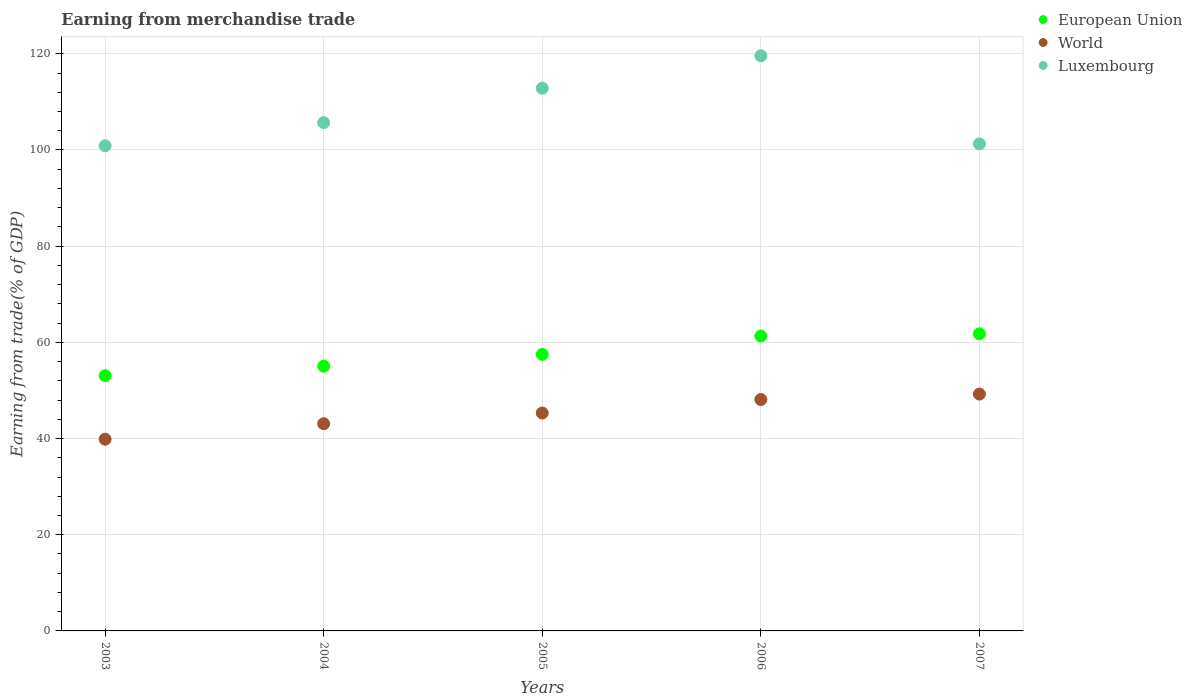How many different coloured dotlines are there?
Offer a terse response. 3. What is the earnings from trade in World in 2003?
Your answer should be compact. 39.86. Across all years, what is the maximum earnings from trade in World?
Your answer should be very brief. 49.24. Across all years, what is the minimum earnings from trade in European Union?
Offer a terse response. 53.07. In which year was the earnings from trade in Luxembourg maximum?
Your answer should be compact. 2006. What is the total earnings from trade in World in the graph?
Your response must be concise. 225.61. What is the difference between the earnings from trade in World in 2004 and that in 2005?
Your answer should be very brief. -2.23. What is the difference between the earnings from trade in European Union in 2004 and the earnings from trade in Luxembourg in 2003?
Offer a terse response. -45.81. What is the average earnings from trade in European Union per year?
Provide a succinct answer. 57.75. In the year 2006, what is the difference between the earnings from trade in Luxembourg and earnings from trade in European Union?
Ensure brevity in your answer.  58.27. In how many years, is the earnings from trade in European Union greater than 108 %?
Offer a very short reply. 0. What is the ratio of the earnings from trade in World in 2004 to that in 2005?
Your response must be concise. 0.95. Is the difference between the earnings from trade in Luxembourg in 2006 and 2007 greater than the difference between the earnings from trade in European Union in 2006 and 2007?
Offer a very short reply. Yes. What is the difference between the highest and the second highest earnings from trade in Luxembourg?
Provide a succinct answer. 6.74. What is the difference between the highest and the lowest earnings from trade in European Union?
Provide a succinct answer. 8.71. Is the earnings from trade in World strictly greater than the earnings from trade in European Union over the years?
Keep it short and to the point. No. Is the earnings from trade in European Union strictly less than the earnings from trade in World over the years?
Offer a very short reply. No. How many dotlines are there?
Ensure brevity in your answer.  3. What is the difference between two consecutive major ticks on the Y-axis?
Make the answer very short. 20. Are the values on the major ticks of Y-axis written in scientific E-notation?
Keep it short and to the point. No. Does the graph contain any zero values?
Your response must be concise. No. Where does the legend appear in the graph?
Keep it short and to the point. Top right. How many legend labels are there?
Your answer should be very brief. 3. What is the title of the graph?
Your answer should be compact. Earning from merchandise trade. Does "Georgia" appear as one of the legend labels in the graph?
Give a very brief answer. No. What is the label or title of the Y-axis?
Give a very brief answer. Earning from trade(% of GDP). What is the Earning from trade(% of GDP) in European Union in 2003?
Provide a short and direct response. 53.07. What is the Earning from trade(% of GDP) in World in 2003?
Your answer should be compact. 39.86. What is the Earning from trade(% of GDP) in Luxembourg in 2003?
Offer a very short reply. 100.87. What is the Earning from trade(% of GDP) of European Union in 2004?
Offer a very short reply. 55.06. What is the Earning from trade(% of GDP) in World in 2004?
Offer a terse response. 43.08. What is the Earning from trade(% of GDP) in Luxembourg in 2004?
Your response must be concise. 105.68. What is the Earning from trade(% of GDP) of European Union in 2005?
Provide a short and direct response. 57.5. What is the Earning from trade(% of GDP) of World in 2005?
Give a very brief answer. 45.31. What is the Earning from trade(% of GDP) in Luxembourg in 2005?
Ensure brevity in your answer.  112.85. What is the Earning from trade(% of GDP) in European Union in 2006?
Your response must be concise. 61.32. What is the Earning from trade(% of GDP) in World in 2006?
Your answer should be very brief. 48.12. What is the Earning from trade(% of GDP) in Luxembourg in 2006?
Your response must be concise. 119.59. What is the Earning from trade(% of GDP) of European Union in 2007?
Provide a succinct answer. 61.78. What is the Earning from trade(% of GDP) in World in 2007?
Your response must be concise. 49.24. What is the Earning from trade(% of GDP) in Luxembourg in 2007?
Ensure brevity in your answer.  101.27. Across all years, what is the maximum Earning from trade(% of GDP) in European Union?
Offer a terse response. 61.78. Across all years, what is the maximum Earning from trade(% of GDP) of World?
Your answer should be very brief. 49.24. Across all years, what is the maximum Earning from trade(% of GDP) in Luxembourg?
Offer a very short reply. 119.59. Across all years, what is the minimum Earning from trade(% of GDP) in European Union?
Your response must be concise. 53.07. Across all years, what is the minimum Earning from trade(% of GDP) in World?
Your answer should be compact. 39.86. Across all years, what is the minimum Earning from trade(% of GDP) in Luxembourg?
Offer a very short reply. 100.87. What is the total Earning from trade(% of GDP) of European Union in the graph?
Provide a short and direct response. 288.74. What is the total Earning from trade(% of GDP) in World in the graph?
Make the answer very short. 225.61. What is the total Earning from trade(% of GDP) in Luxembourg in the graph?
Keep it short and to the point. 540.26. What is the difference between the Earning from trade(% of GDP) in European Union in 2003 and that in 2004?
Your response must be concise. -1.99. What is the difference between the Earning from trade(% of GDP) in World in 2003 and that in 2004?
Provide a short and direct response. -3.22. What is the difference between the Earning from trade(% of GDP) of Luxembourg in 2003 and that in 2004?
Your answer should be very brief. -4.81. What is the difference between the Earning from trade(% of GDP) in European Union in 2003 and that in 2005?
Offer a very short reply. -4.43. What is the difference between the Earning from trade(% of GDP) of World in 2003 and that in 2005?
Your answer should be compact. -5.45. What is the difference between the Earning from trade(% of GDP) of Luxembourg in 2003 and that in 2005?
Your response must be concise. -11.97. What is the difference between the Earning from trade(% of GDP) of European Union in 2003 and that in 2006?
Offer a terse response. -8.25. What is the difference between the Earning from trade(% of GDP) of World in 2003 and that in 2006?
Keep it short and to the point. -8.26. What is the difference between the Earning from trade(% of GDP) of Luxembourg in 2003 and that in 2006?
Offer a very short reply. -18.72. What is the difference between the Earning from trade(% of GDP) in European Union in 2003 and that in 2007?
Your answer should be compact. -8.71. What is the difference between the Earning from trade(% of GDP) in World in 2003 and that in 2007?
Your response must be concise. -9.38. What is the difference between the Earning from trade(% of GDP) in Luxembourg in 2003 and that in 2007?
Your response must be concise. -0.4. What is the difference between the Earning from trade(% of GDP) of European Union in 2004 and that in 2005?
Your answer should be very brief. -2.44. What is the difference between the Earning from trade(% of GDP) in World in 2004 and that in 2005?
Keep it short and to the point. -2.23. What is the difference between the Earning from trade(% of GDP) of Luxembourg in 2004 and that in 2005?
Offer a very short reply. -7.16. What is the difference between the Earning from trade(% of GDP) in European Union in 2004 and that in 2006?
Provide a short and direct response. -6.26. What is the difference between the Earning from trade(% of GDP) in World in 2004 and that in 2006?
Your response must be concise. -5.04. What is the difference between the Earning from trade(% of GDP) in Luxembourg in 2004 and that in 2006?
Provide a succinct answer. -13.9. What is the difference between the Earning from trade(% of GDP) in European Union in 2004 and that in 2007?
Offer a terse response. -6.72. What is the difference between the Earning from trade(% of GDP) in World in 2004 and that in 2007?
Make the answer very short. -6.16. What is the difference between the Earning from trade(% of GDP) of Luxembourg in 2004 and that in 2007?
Provide a succinct answer. 4.41. What is the difference between the Earning from trade(% of GDP) in European Union in 2005 and that in 2006?
Ensure brevity in your answer.  -3.82. What is the difference between the Earning from trade(% of GDP) of World in 2005 and that in 2006?
Your response must be concise. -2.81. What is the difference between the Earning from trade(% of GDP) of Luxembourg in 2005 and that in 2006?
Your response must be concise. -6.74. What is the difference between the Earning from trade(% of GDP) of European Union in 2005 and that in 2007?
Provide a short and direct response. -4.28. What is the difference between the Earning from trade(% of GDP) of World in 2005 and that in 2007?
Make the answer very short. -3.94. What is the difference between the Earning from trade(% of GDP) of Luxembourg in 2005 and that in 2007?
Your answer should be very brief. 11.58. What is the difference between the Earning from trade(% of GDP) of European Union in 2006 and that in 2007?
Give a very brief answer. -0.46. What is the difference between the Earning from trade(% of GDP) of World in 2006 and that in 2007?
Ensure brevity in your answer.  -1.12. What is the difference between the Earning from trade(% of GDP) of Luxembourg in 2006 and that in 2007?
Your response must be concise. 18.32. What is the difference between the Earning from trade(% of GDP) in European Union in 2003 and the Earning from trade(% of GDP) in World in 2004?
Make the answer very short. 9.99. What is the difference between the Earning from trade(% of GDP) of European Union in 2003 and the Earning from trade(% of GDP) of Luxembourg in 2004?
Your answer should be compact. -52.61. What is the difference between the Earning from trade(% of GDP) of World in 2003 and the Earning from trade(% of GDP) of Luxembourg in 2004?
Your answer should be very brief. -65.83. What is the difference between the Earning from trade(% of GDP) in European Union in 2003 and the Earning from trade(% of GDP) in World in 2005?
Your answer should be very brief. 7.77. What is the difference between the Earning from trade(% of GDP) in European Union in 2003 and the Earning from trade(% of GDP) in Luxembourg in 2005?
Your answer should be compact. -59.77. What is the difference between the Earning from trade(% of GDP) in World in 2003 and the Earning from trade(% of GDP) in Luxembourg in 2005?
Keep it short and to the point. -72.99. What is the difference between the Earning from trade(% of GDP) in European Union in 2003 and the Earning from trade(% of GDP) in World in 2006?
Ensure brevity in your answer.  4.95. What is the difference between the Earning from trade(% of GDP) in European Union in 2003 and the Earning from trade(% of GDP) in Luxembourg in 2006?
Your answer should be very brief. -66.52. What is the difference between the Earning from trade(% of GDP) in World in 2003 and the Earning from trade(% of GDP) in Luxembourg in 2006?
Your answer should be very brief. -79.73. What is the difference between the Earning from trade(% of GDP) of European Union in 2003 and the Earning from trade(% of GDP) of World in 2007?
Your answer should be very brief. 3.83. What is the difference between the Earning from trade(% of GDP) of European Union in 2003 and the Earning from trade(% of GDP) of Luxembourg in 2007?
Provide a succinct answer. -48.2. What is the difference between the Earning from trade(% of GDP) of World in 2003 and the Earning from trade(% of GDP) of Luxembourg in 2007?
Provide a short and direct response. -61.41. What is the difference between the Earning from trade(% of GDP) in European Union in 2004 and the Earning from trade(% of GDP) in World in 2005?
Offer a terse response. 9.76. What is the difference between the Earning from trade(% of GDP) of European Union in 2004 and the Earning from trade(% of GDP) of Luxembourg in 2005?
Provide a short and direct response. -57.78. What is the difference between the Earning from trade(% of GDP) of World in 2004 and the Earning from trade(% of GDP) of Luxembourg in 2005?
Provide a short and direct response. -69.76. What is the difference between the Earning from trade(% of GDP) in European Union in 2004 and the Earning from trade(% of GDP) in World in 2006?
Offer a very short reply. 6.94. What is the difference between the Earning from trade(% of GDP) in European Union in 2004 and the Earning from trade(% of GDP) in Luxembourg in 2006?
Make the answer very short. -64.53. What is the difference between the Earning from trade(% of GDP) of World in 2004 and the Earning from trade(% of GDP) of Luxembourg in 2006?
Provide a succinct answer. -76.51. What is the difference between the Earning from trade(% of GDP) in European Union in 2004 and the Earning from trade(% of GDP) in World in 2007?
Offer a very short reply. 5.82. What is the difference between the Earning from trade(% of GDP) in European Union in 2004 and the Earning from trade(% of GDP) in Luxembourg in 2007?
Provide a succinct answer. -46.21. What is the difference between the Earning from trade(% of GDP) in World in 2004 and the Earning from trade(% of GDP) in Luxembourg in 2007?
Provide a short and direct response. -58.19. What is the difference between the Earning from trade(% of GDP) in European Union in 2005 and the Earning from trade(% of GDP) in World in 2006?
Offer a very short reply. 9.38. What is the difference between the Earning from trade(% of GDP) in European Union in 2005 and the Earning from trade(% of GDP) in Luxembourg in 2006?
Provide a succinct answer. -62.09. What is the difference between the Earning from trade(% of GDP) of World in 2005 and the Earning from trade(% of GDP) of Luxembourg in 2006?
Your answer should be compact. -74.28. What is the difference between the Earning from trade(% of GDP) of European Union in 2005 and the Earning from trade(% of GDP) of World in 2007?
Provide a short and direct response. 8.26. What is the difference between the Earning from trade(% of GDP) of European Union in 2005 and the Earning from trade(% of GDP) of Luxembourg in 2007?
Ensure brevity in your answer.  -43.77. What is the difference between the Earning from trade(% of GDP) in World in 2005 and the Earning from trade(% of GDP) in Luxembourg in 2007?
Offer a terse response. -55.96. What is the difference between the Earning from trade(% of GDP) of European Union in 2006 and the Earning from trade(% of GDP) of World in 2007?
Provide a succinct answer. 12.08. What is the difference between the Earning from trade(% of GDP) of European Union in 2006 and the Earning from trade(% of GDP) of Luxembourg in 2007?
Offer a terse response. -39.95. What is the difference between the Earning from trade(% of GDP) in World in 2006 and the Earning from trade(% of GDP) in Luxembourg in 2007?
Your response must be concise. -53.15. What is the average Earning from trade(% of GDP) of European Union per year?
Your answer should be very brief. 57.75. What is the average Earning from trade(% of GDP) of World per year?
Make the answer very short. 45.12. What is the average Earning from trade(% of GDP) in Luxembourg per year?
Ensure brevity in your answer.  108.05. In the year 2003, what is the difference between the Earning from trade(% of GDP) in European Union and Earning from trade(% of GDP) in World?
Your answer should be compact. 13.21. In the year 2003, what is the difference between the Earning from trade(% of GDP) in European Union and Earning from trade(% of GDP) in Luxembourg?
Provide a succinct answer. -47.8. In the year 2003, what is the difference between the Earning from trade(% of GDP) in World and Earning from trade(% of GDP) in Luxembourg?
Your answer should be very brief. -61.02. In the year 2004, what is the difference between the Earning from trade(% of GDP) of European Union and Earning from trade(% of GDP) of World?
Keep it short and to the point. 11.98. In the year 2004, what is the difference between the Earning from trade(% of GDP) of European Union and Earning from trade(% of GDP) of Luxembourg?
Keep it short and to the point. -50.62. In the year 2004, what is the difference between the Earning from trade(% of GDP) in World and Earning from trade(% of GDP) in Luxembourg?
Offer a very short reply. -62.6. In the year 2005, what is the difference between the Earning from trade(% of GDP) in European Union and Earning from trade(% of GDP) in World?
Your answer should be very brief. 12.19. In the year 2005, what is the difference between the Earning from trade(% of GDP) in European Union and Earning from trade(% of GDP) in Luxembourg?
Keep it short and to the point. -55.34. In the year 2005, what is the difference between the Earning from trade(% of GDP) of World and Earning from trade(% of GDP) of Luxembourg?
Your answer should be very brief. -67.54. In the year 2006, what is the difference between the Earning from trade(% of GDP) of European Union and Earning from trade(% of GDP) of World?
Your response must be concise. 13.2. In the year 2006, what is the difference between the Earning from trade(% of GDP) in European Union and Earning from trade(% of GDP) in Luxembourg?
Offer a very short reply. -58.27. In the year 2006, what is the difference between the Earning from trade(% of GDP) in World and Earning from trade(% of GDP) in Luxembourg?
Your answer should be very brief. -71.47. In the year 2007, what is the difference between the Earning from trade(% of GDP) of European Union and Earning from trade(% of GDP) of World?
Provide a succinct answer. 12.54. In the year 2007, what is the difference between the Earning from trade(% of GDP) of European Union and Earning from trade(% of GDP) of Luxembourg?
Offer a terse response. -39.49. In the year 2007, what is the difference between the Earning from trade(% of GDP) of World and Earning from trade(% of GDP) of Luxembourg?
Make the answer very short. -52.03. What is the ratio of the Earning from trade(% of GDP) of European Union in 2003 to that in 2004?
Offer a very short reply. 0.96. What is the ratio of the Earning from trade(% of GDP) of World in 2003 to that in 2004?
Your response must be concise. 0.93. What is the ratio of the Earning from trade(% of GDP) in Luxembourg in 2003 to that in 2004?
Your answer should be compact. 0.95. What is the ratio of the Earning from trade(% of GDP) in European Union in 2003 to that in 2005?
Ensure brevity in your answer.  0.92. What is the ratio of the Earning from trade(% of GDP) of World in 2003 to that in 2005?
Offer a very short reply. 0.88. What is the ratio of the Earning from trade(% of GDP) of Luxembourg in 2003 to that in 2005?
Your answer should be compact. 0.89. What is the ratio of the Earning from trade(% of GDP) in European Union in 2003 to that in 2006?
Ensure brevity in your answer.  0.87. What is the ratio of the Earning from trade(% of GDP) in World in 2003 to that in 2006?
Ensure brevity in your answer.  0.83. What is the ratio of the Earning from trade(% of GDP) of Luxembourg in 2003 to that in 2006?
Provide a succinct answer. 0.84. What is the ratio of the Earning from trade(% of GDP) of European Union in 2003 to that in 2007?
Provide a succinct answer. 0.86. What is the ratio of the Earning from trade(% of GDP) in World in 2003 to that in 2007?
Your answer should be very brief. 0.81. What is the ratio of the Earning from trade(% of GDP) in European Union in 2004 to that in 2005?
Provide a short and direct response. 0.96. What is the ratio of the Earning from trade(% of GDP) in World in 2004 to that in 2005?
Keep it short and to the point. 0.95. What is the ratio of the Earning from trade(% of GDP) in Luxembourg in 2004 to that in 2005?
Provide a short and direct response. 0.94. What is the ratio of the Earning from trade(% of GDP) in European Union in 2004 to that in 2006?
Provide a succinct answer. 0.9. What is the ratio of the Earning from trade(% of GDP) of World in 2004 to that in 2006?
Provide a short and direct response. 0.9. What is the ratio of the Earning from trade(% of GDP) of Luxembourg in 2004 to that in 2006?
Your answer should be compact. 0.88. What is the ratio of the Earning from trade(% of GDP) of European Union in 2004 to that in 2007?
Your answer should be compact. 0.89. What is the ratio of the Earning from trade(% of GDP) in World in 2004 to that in 2007?
Your answer should be compact. 0.87. What is the ratio of the Earning from trade(% of GDP) in Luxembourg in 2004 to that in 2007?
Provide a succinct answer. 1.04. What is the ratio of the Earning from trade(% of GDP) in European Union in 2005 to that in 2006?
Keep it short and to the point. 0.94. What is the ratio of the Earning from trade(% of GDP) in World in 2005 to that in 2006?
Keep it short and to the point. 0.94. What is the ratio of the Earning from trade(% of GDP) in Luxembourg in 2005 to that in 2006?
Offer a terse response. 0.94. What is the ratio of the Earning from trade(% of GDP) of European Union in 2005 to that in 2007?
Your response must be concise. 0.93. What is the ratio of the Earning from trade(% of GDP) of World in 2005 to that in 2007?
Provide a short and direct response. 0.92. What is the ratio of the Earning from trade(% of GDP) of Luxembourg in 2005 to that in 2007?
Offer a terse response. 1.11. What is the ratio of the Earning from trade(% of GDP) in European Union in 2006 to that in 2007?
Your answer should be compact. 0.99. What is the ratio of the Earning from trade(% of GDP) in World in 2006 to that in 2007?
Your response must be concise. 0.98. What is the ratio of the Earning from trade(% of GDP) of Luxembourg in 2006 to that in 2007?
Your answer should be very brief. 1.18. What is the difference between the highest and the second highest Earning from trade(% of GDP) in European Union?
Ensure brevity in your answer.  0.46. What is the difference between the highest and the second highest Earning from trade(% of GDP) in World?
Provide a short and direct response. 1.12. What is the difference between the highest and the second highest Earning from trade(% of GDP) of Luxembourg?
Your answer should be compact. 6.74. What is the difference between the highest and the lowest Earning from trade(% of GDP) of European Union?
Provide a short and direct response. 8.71. What is the difference between the highest and the lowest Earning from trade(% of GDP) in World?
Your answer should be compact. 9.38. What is the difference between the highest and the lowest Earning from trade(% of GDP) of Luxembourg?
Make the answer very short. 18.72. 